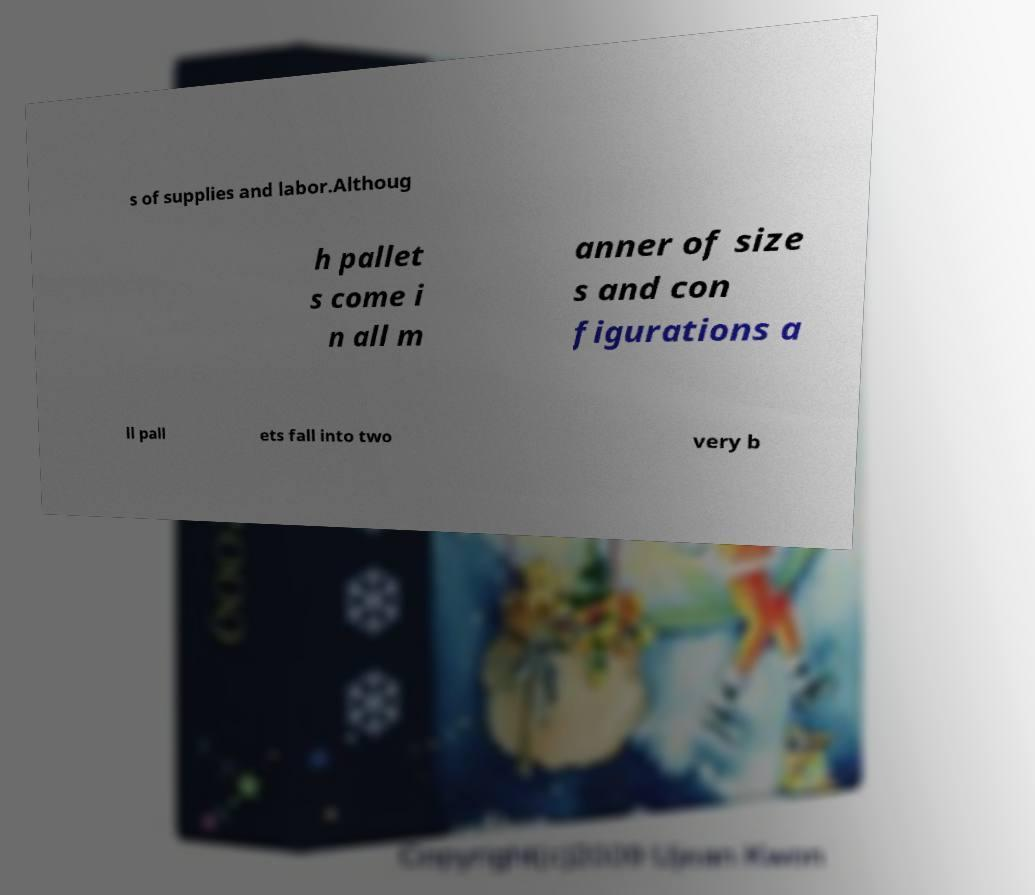Can you accurately transcribe the text from the provided image for me? s of supplies and labor.Althoug h pallet s come i n all m anner of size s and con figurations a ll pall ets fall into two very b 